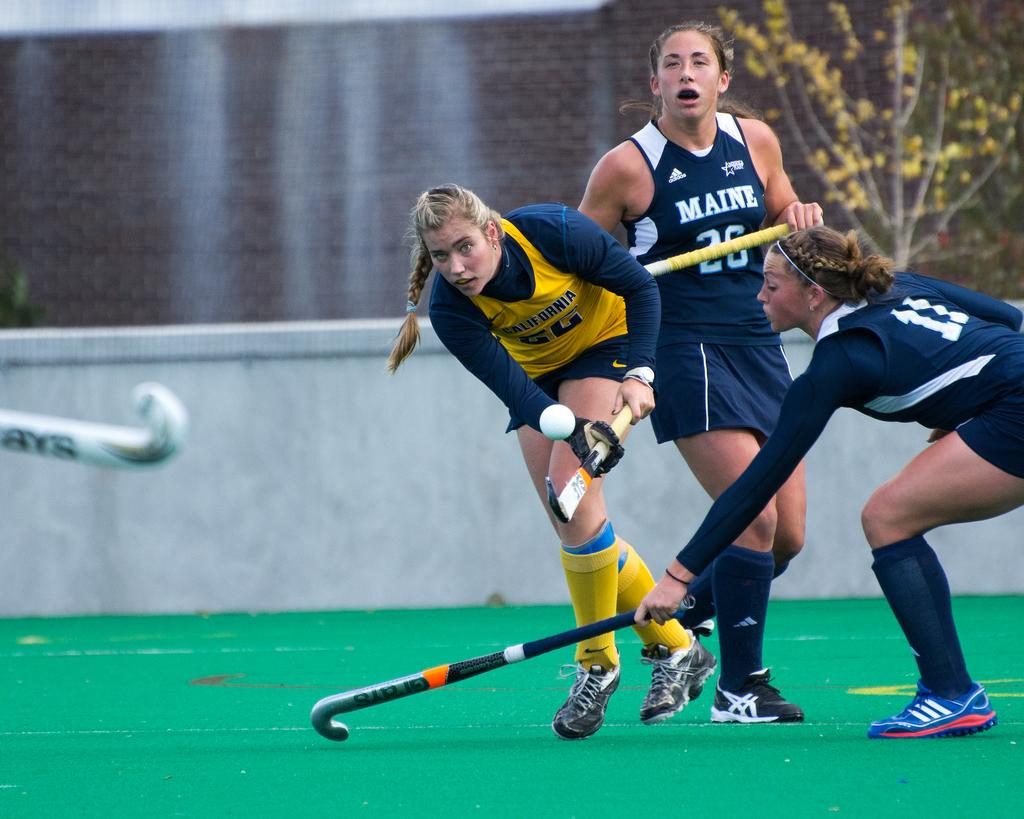<image>
Give a short and clear explanation of the subsequent image. A group of girls playing field hockey in maine. 